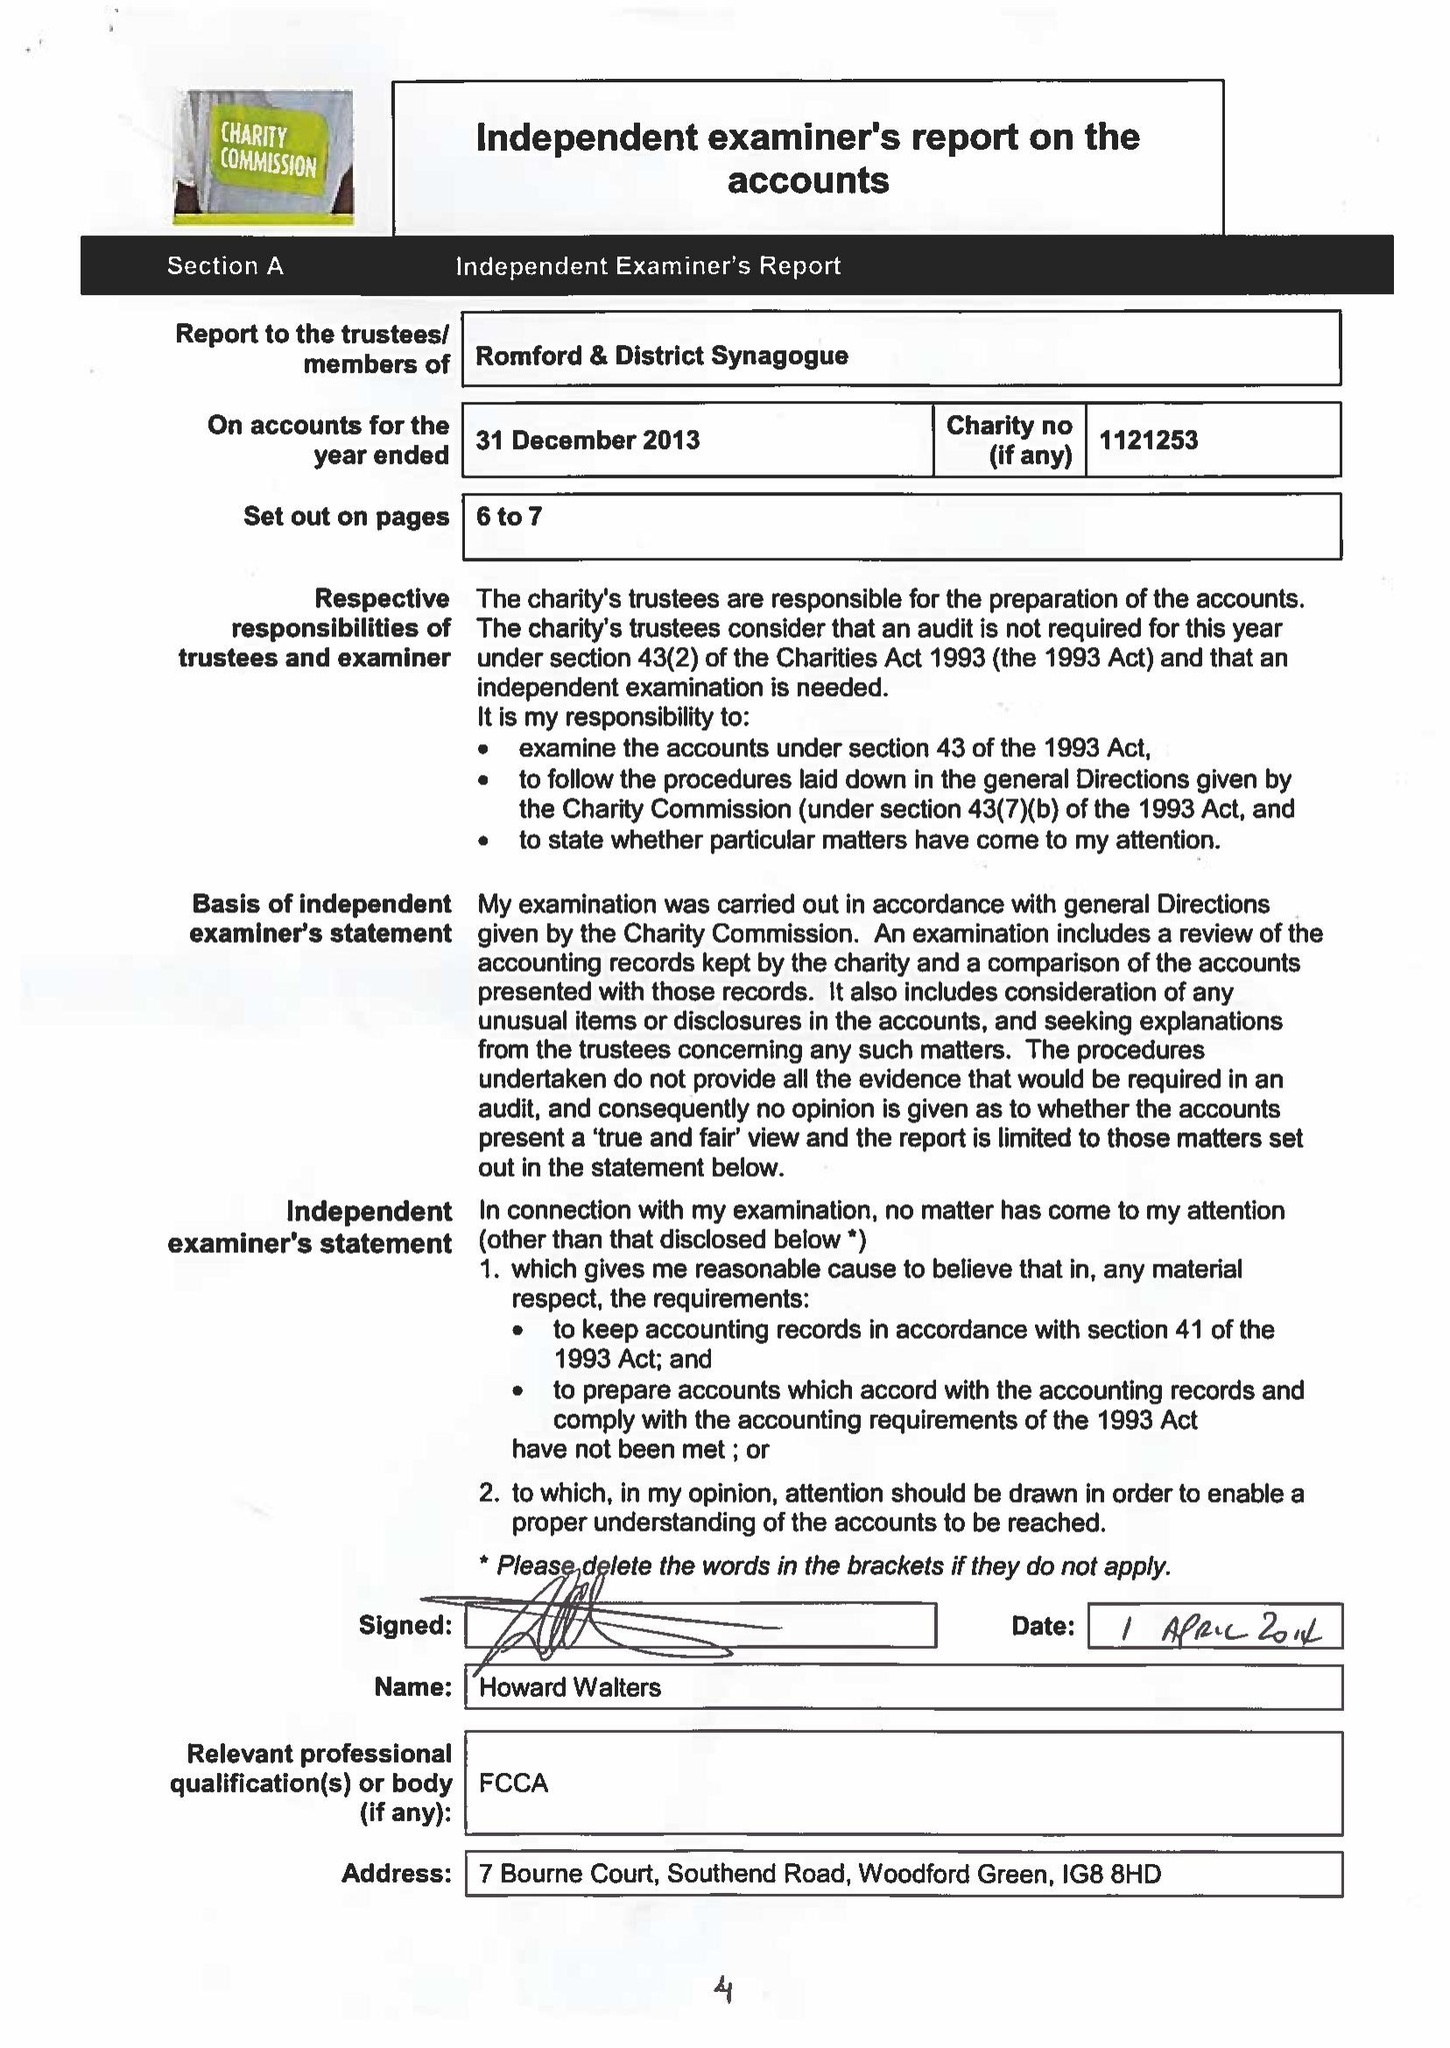What is the value for the charity_number?
Answer the question using a single word or phrase. 1121253 